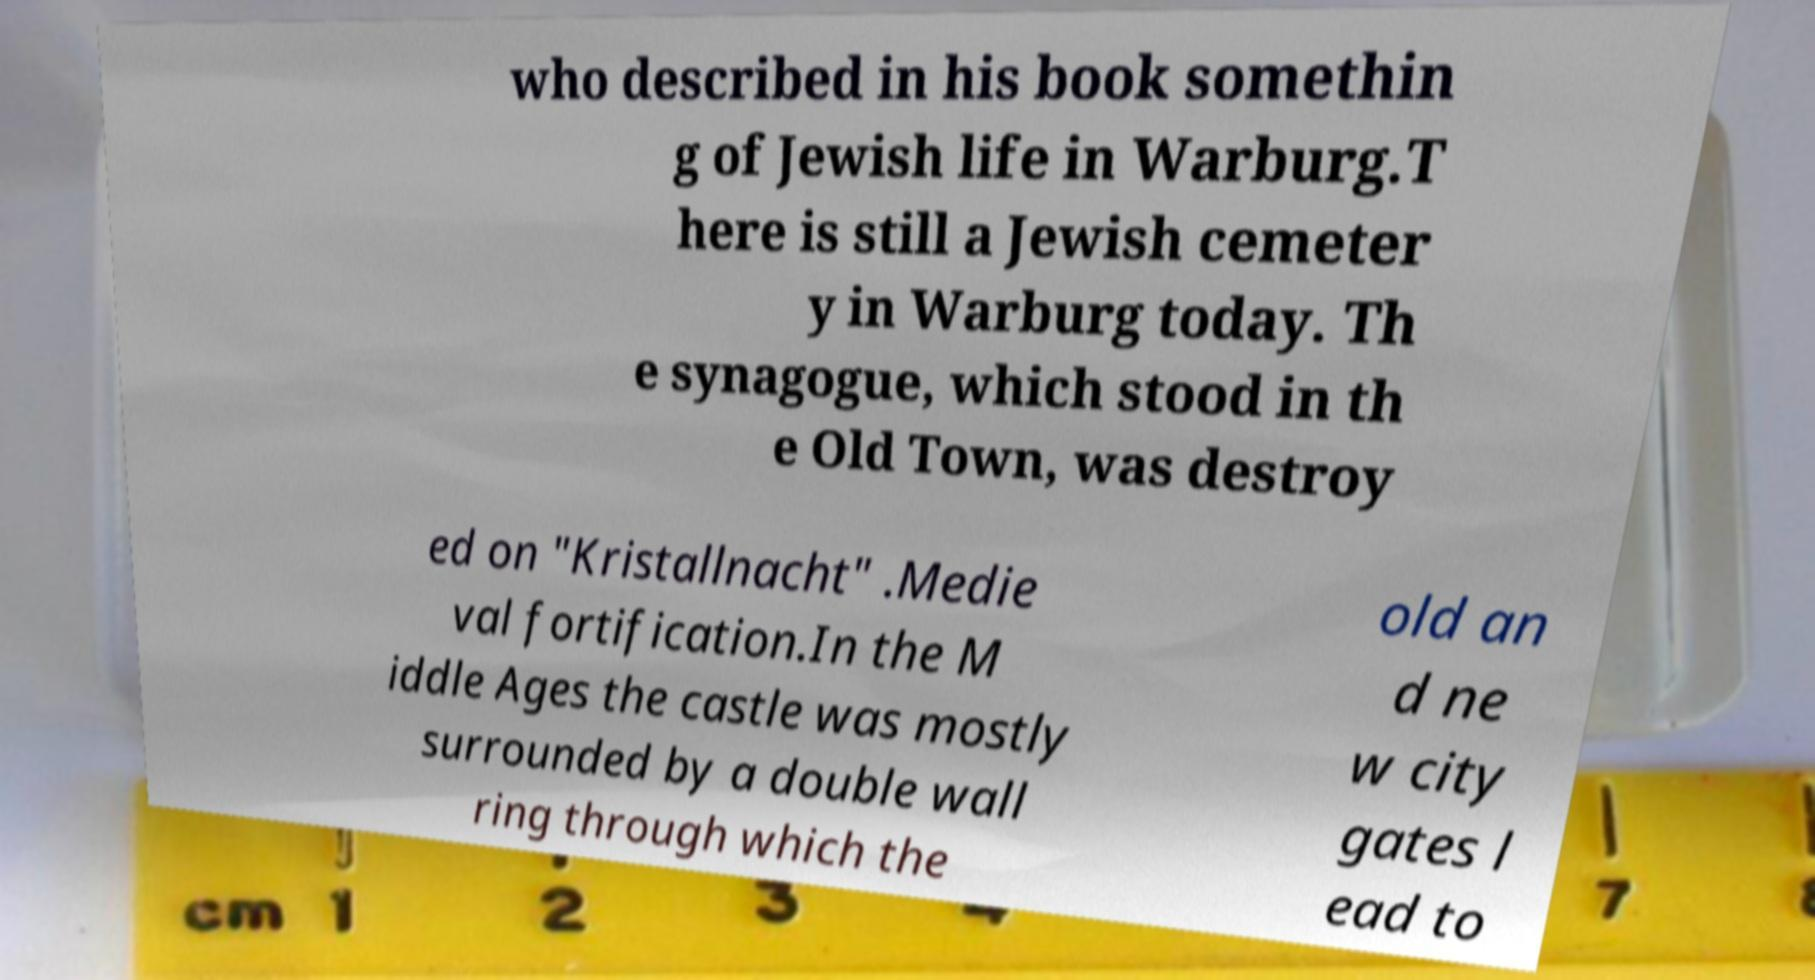Could you assist in decoding the text presented in this image and type it out clearly? who described in his book somethin g of Jewish life in Warburg.T here is still a Jewish cemeter y in Warburg today. Th e synagogue, which stood in th e Old Town, was destroy ed on "Kristallnacht" .Medie val fortification.In the M iddle Ages the castle was mostly surrounded by a double wall ring through which the old an d ne w city gates l ead to 